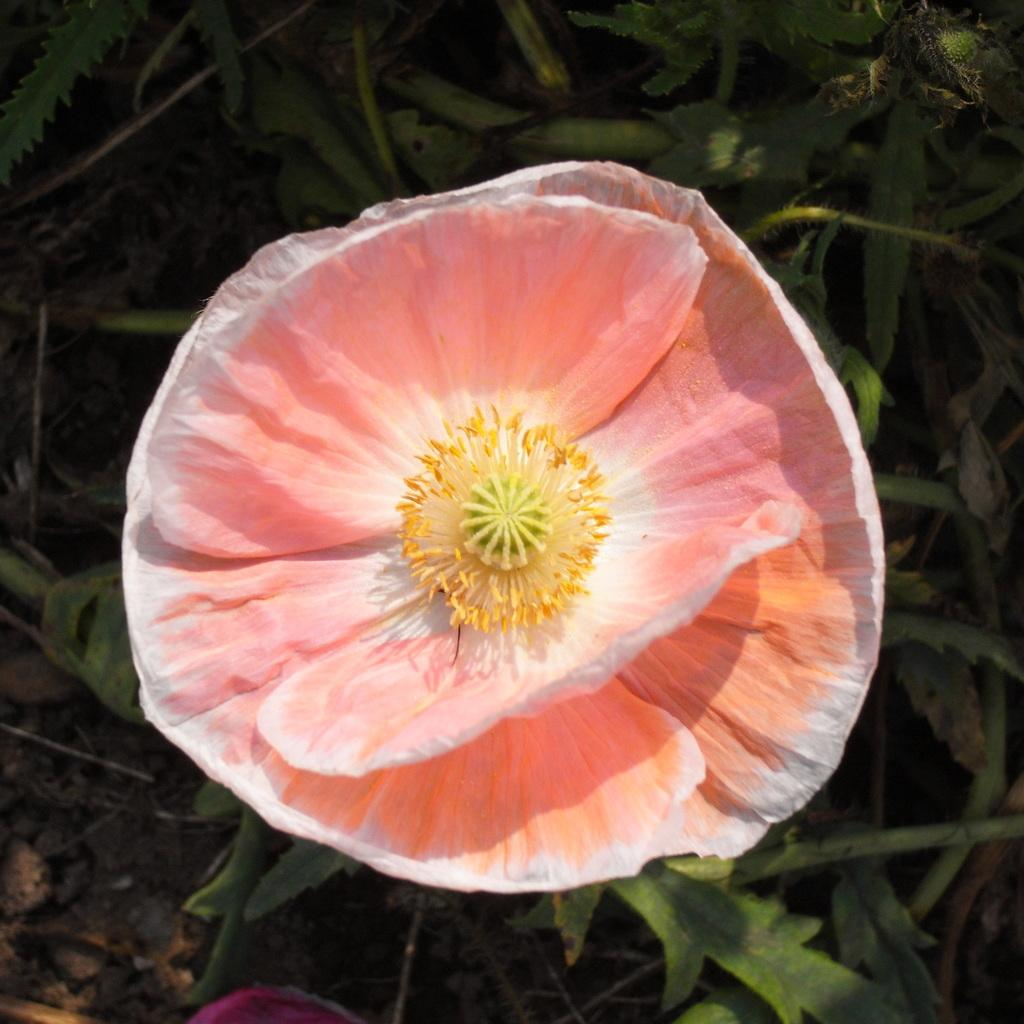What type of flower is visible in the image? There is a pink flower in the image. What else can be seen in the background of the image? There are plants in the background of the image. How does the flower show respect to the market in the image? There is no market present in the image, and flowers do not have the ability to show respect. 